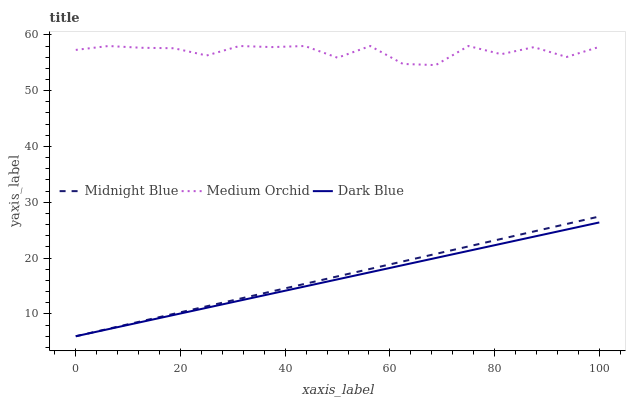Does Dark Blue have the minimum area under the curve?
Answer yes or no. Yes. Does Medium Orchid have the maximum area under the curve?
Answer yes or no. Yes. Does Midnight Blue have the minimum area under the curve?
Answer yes or no. No. Does Midnight Blue have the maximum area under the curve?
Answer yes or no. No. Is Midnight Blue the smoothest?
Answer yes or no. Yes. Is Medium Orchid the roughest?
Answer yes or no. Yes. Is Medium Orchid the smoothest?
Answer yes or no. No. Is Midnight Blue the roughest?
Answer yes or no. No. Does Dark Blue have the lowest value?
Answer yes or no. Yes. Does Medium Orchid have the lowest value?
Answer yes or no. No. Does Medium Orchid have the highest value?
Answer yes or no. Yes. Does Midnight Blue have the highest value?
Answer yes or no. No. Is Dark Blue less than Medium Orchid?
Answer yes or no. Yes. Is Medium Orchid greater than Dark Blue?
Answer yes or no. Yes. Does Midnight Blue intersect Dark Blue?
Answer yes or no. Yes. Is Midnight Blue less than Dark Blue?
Answer yes or no. No. Is Midnight Blue greater than Dark Blue?
Answer yes or no. No. Does Dark Blue intersect Medium Orchid?
Answer yes or no. No. 